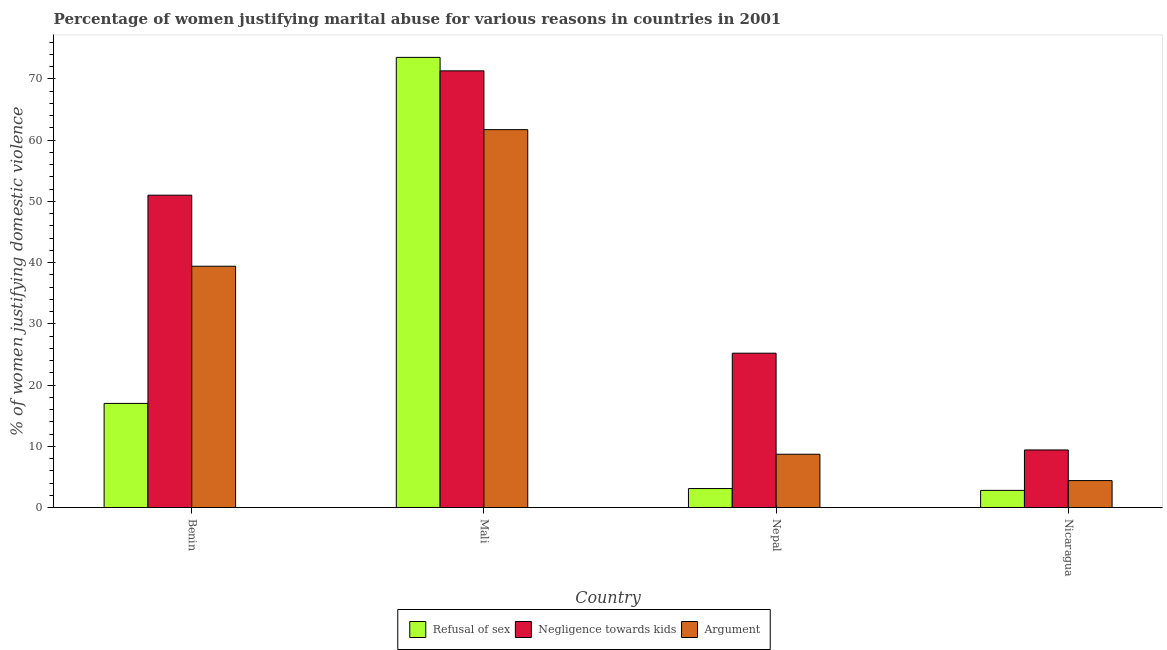Are the number of bars per tick equal to the number of legend labels?
Keep it short and to the point. Yes. What is the label of the 3rd group of bars from the left?
Ensure brevity in your answer.  Nepal. What is the percentage of women justifying domestic violence due to refusal of sex in Benin?
Your answer should be very brief. 17. Across all countries, what is the maximum percentage of women justifying domestic violence due to negligence towards kids?
Ensure brevity in your answer.  71.3. In which country was the percentage of women justifying domestic violence due to refusal of sex maximum?
Offer a terse response. Mali. In which country was the percentage of women justifying domestic violence due to refusal of sex minimum?
Keep it short and to the point. Nicaragua. What is the total percentage of women justifying domestic violence due to arguments in the graph?
Offer a terse response. 114.2. What is the difference between the percentage of women justifying domestic violence due to refusal of sex in Nepal and that in Nicaragua?
Provide a short and direct response. 0.3. What is the difference between the percentage of women justifying domestic violence due to negligence towards kids in Mali and the percentage of women justifying domestic violence due to refusal of sex in Nepal?
Ensure brevity in your answer.  68.2. What is the average percentage of women justifying domestic violence due to arguments per country?
Provide a short and direct response. 28.55. What is the difference between the percentage of women justifying domestic violence due to negligence towards kids and percentage of women justifying domestic violence due to refusal of sex in Mali?
Ensure brevity in your answer.  -2.2. What is the ratio of the percentage of women justifying domestic violence due to refusal of sex in Mali to that in Nicaragua?
Offer a terse response. 26.25. Is the percentage of women justifying domestic violence due to negligence towards kids in Mali less than that in Nepal?
Your answer should be very brief. No. What is the difference between the highest and the second highest percentage of women justifying domestic violence due to negligence towards kids?
Your answer should be compact. 20.3. What is the difference between the highest and the lowest percentage of women justifying domestic violence due to negligence towards kids?
Provide a succinct answer. 61.9. In how many countries, is the percentage of women justifying domestic violence due to refusal of sex greater than the average percentage of women justifying domestic violence due to refusal of sex taken over all countries?
Keep it short and to the point. 1. What does the 2nd bar from the left in Nicaragua represents?
Your answer should be very brief. Negligence towards kids. What does the 1st bar from the right in Mali represents?
Provide a succinct answer. Argument. Are all the bars in the graph horizontal?
Your answer should be very brief. No. How many countries are there in the graph?
Keep it short and to the point. 4. What is the difference between two consecutive major ticks on the Y-axis?
Your response must be concise. 10. Are the values on the major ticks of Y-axis written in scientific E-notation?
Provide a succinct answer. No. Does the graph contain any zero values?
Provide a short and direct response. No. Does the graph contain grids?
Give a very brief answer. No. Where does the legend appear in the graph?
Provide a succinct answer. Bottom center. How many legend labels are there?
Your response must be concise. 3. How are the legend labels stacked?
Provide a succinct answer. Horizontal. What is the title of the graph?
Your response must be concise. Percentage of women justifying marital abuse for various reasons in countries in 2001. What is the label or title of the X-axis?
Offer a very short reply. Country. What is the label or title of the Y-axis?
Provide a short and direct response. % of women justifying domestic violence. What is the % of women justifying domestic violence of Refusal of sex in Benin?
Give a very brief answer. 17. What is the % of women justifying domestic violence of Negligence towards kids in Benin?
Offer a terse response. 51. What is the % of women justifying domestic violence in Argument in Benin?
Make the answer very short. 39.4. What is the % of women justifying domestic violence in Refusal of sex in Mali?
Keep it short and to the point. 73.5. What is the % of women justifying domestic violence of Negligence towards kids in Mali?
Give a very brief answer. 71.3. What is the % of women justifying domestic violence of Argument in Mali?
Provide a succinct answer. 61.7. What is the % of women justifying domestic violence in Refusal of sex in Nepal?
Your answer should be very brief. 3.1. What is the % of women justifying domestic violence in Negligence towards kids in Nepal?
Give a very brief answer. 25.2. What is the % of women justifying domestic violence of Argument in Nepal?
Your response must be concise. 8.7. What is the % of women justifying domestic violence in Refusal of sex in Nicaragua?
Give a very brief answer. 2.8. What is the % of women justifying domestic violence in Argument in Nicaragua?
Give a very brief answer. 4.4. Across all countries, what is the maximum % of women justifying domestic violence of Refusal of sex?
Give a very brief answer. 73.5. Across all countries, what is the maximum % of women justifying domestic violence of Negligence towards kids?
Offer a very short reply. 71.3. Across all countries, what is the maximum % of women justifying domestic violence in Argument?
Provide a short and direct response. 61.7. Across all countries, what is the minimum % of women justifying domestic violence of Refusal of sex?
Give a very brief answer. 2.8. Across all countries, what is the minimum % of women justifying domestic violence of Negligence towards kids?
Give a very brief answer. 9.4. Across all countries, what is the minimum % of women justifying domestic violence of Argument?
Keep it short and to the point. 4.4. What is the total % of women justifying domestic violence of Refusal of sex in the graph?
Provide a succinct answer. 96.4. What is the total % of women justifying domestic violence of Negligence towards kids in the graph?
Ensure brevity in your answer.  156.9. What is the total % of women justifying domestic violence in Argument in the graph?
Provide a short and direct response. 114.2. What is the difference between the % of women justifying domestic violence of Refusal of sex in Benin and that in Mali?
Give a very brief answer. -56.5. What is the difference between the % of women justifying domestic violence of Negligence towards kids in Benin and that in Mali?
Provide a succinct answer. -20.3. What is the difference between the % of women justifying domestic violence in Argument in Benin and that in Mali?
Make the answer very short. -22.3. What is the difference between the % of women justifying domestic violence of Refusal of sex in Benin and that in Nepal?
Your answer should be very brief. 13.9. What is the difference between the % of women justifying domestic violence in Negligence towards kids in Benin and that in Nepal?
Keep it short and to the point. 25.8. What is the difference between the % of women justifying domestic violence in Argument in Benin and that in Nepal?
Ensure brevity in your answer.  30.7. What is the difference between the % of women justifying domestic violence in Negligence towards kids in Benin and that in Nicaragua?
Offer a very short reply. 41.6. What is the difference between the % of women justifying domestic violence in Refusal of sex in Mali and that in Nepal?
Your answer should be very brief. 70.4. What is the difference between the % of women justifying domestic violence in Negligence towards kids in Mali and that in Nepal?
Make the answer very short. 46.1. What is the difference between the % of women justifying domestic violence in Argument in Mali and that in Nepal?
Your response must be concise. 53. What is the difference between the % of women justifying domestic violence in Refusal of sex in Mali and that in Nicaragua?
Your answer should be compact. 70.7. What is the difference between the % of women justifying domestic violence in Negligence towards kids in Mali and that in Nicaragua?
Make the answer very short. 61.9. What is the difference between the % of women justifying domestic violence in Argument in Mali and that in Nicaragua?
Provide a short and direct response. 57.3. What is the difference between the % of women justifying domestic violence of Refusal of sex in Nepal and that in Nicaragua?
Make the answer very short. 0.3. What is the difference between the % of women justifying domestic violence in Refusal of sex in Benin and the % of women justifying domestic violence in Negligence towards kids in Mali?
Provide a short and direct response. -54.3. What is the difference between the % of women justifying domestic violence in Refusal of sex in Benin and the % of women justifying domestic violence in Argument in Mali?
Your response must be concise. -44.7. What is the difference between the % of women justifying domestic violence of Refusal of sex in Benin and the % of women justifying domestic violence of Negligence towards kids in Nepal?
Keep it short and to the point. -8.2. What is the difference between the % of women justifying domestic violence of Negligence towards kids in Benin and the % of women justifying domestic violence of Argument in Nepal?
Your response must be concise. 42.3. What is the difference between the % of women justifying domestic violence of Negligence towards kids in Benin and the % of women justifying domestic violence of Argument in Nicaragua?
Offer a terse response. 46.6. What is the difference between the % of women justifying domestic violence in Refusal of sex in Mali and the % of women justifying domestic violence in Negligence towards kids in Nepal?
Offer a very short reply. 48.3. What is the difference between the % of women justifying domestic violence of Refusal of sex in Mali and the % of women justifying domestic violence of Argument in Nepal?
Make the answer very short. 64.8. What is the difference between the % of women justifying domestic violence in Negligence towards kids in Mali and the % of women justifying domestic violence in Argument in Nepal?
Provide a succinct answer. 62.6. What is the difference between the % of women justifying domestic violence of Refusal of sex in Mali and the % of women justifying domestic violence of Negligence towards kids in Nicaragua?
Offer a very short reply. 64.1. What is the difference between the % of women justifying domestic violence of Refusal of sex in Mali and the % of women justifying domestic violence of Argument in Nicaragua?
Keep it short and to the point. 69.1. What is the difference between the % of women justifying domestic violence of Negligence towards kids in Mali and the % of women justifying domestic violence of Argument in Nicaragua?
Provide a short and direct response. 66.9. What is the difference between the % of women justifying domestic violence of Refusal of sex in Nepal and the % of women justifying domestic violence of Negligence towards kids in Nicaragua?
Offer a very short reply. -6.3. What is the difference between the % of women justifying domestic violence of Refusal of sex in Nepal and the % of women justifying domestic violence of Argument in Nicaragua?
Give a very brief answer. -1.3. What is the difference between the % of women justifying domestic violence in Negligence towards kids in Nepal and the % of women justifying domestic violence in Argument in Nicaragua?
Offer a very short reply. 20.8. What is the average % of women justifying domestic violence in Refusal of sex per country?
Ensure brevity in your answer.  24.1. What is the average % of women justifying domestic violence in Negligence towards kids per country?
Offer a terse response. 39.23. What is the average % of women justifying domestic violence in Argument per country?
Ensure brevity in your answer.  28.55. What is the difference between the % of women justifying domestic violence of Refusal of sex and % of women justifying domestic violence of Negligence towards kids in Benin?
Offer a very short reply. -34. What is the difference between the % of women justifying domestic violence of Refusal of sex and % of women justifying domestic violence of Argument in Benin?
Your answer should be compact. -22.4. What is the difference between the % of women justifying domestic violence of Negligence towards kids and % of women justifying domestic violence of Argument in Benin?
Offer a terse response. 11.6. What is the difference between the % of women justifying domestic violence in Refusal of sex and % of women justifying domestic violence in Negligence towards kids in Mali?
Make the answer very short. 2.2. What is the difference between the % of women justifying domestic violence in Negligence towards kids and % of women justifying domestic violence in Argument in Mali?
Your response must be concise. 9.6. What is the difference between the % of women justifying domestic violence in Refusal of sex and % of women justifying domestic violence in Negligence towards kids in Nepal?
Your answer should be compact. -22.1. What is the difference between the % of women justifying domestic violence of Refusal of sex and % of women justifying domestic violence of Argument in Nepal?
Offer a very short reply. -5.6. What is the difference between the % of women justifying domestic violence of Refusal of sex and % of women justifying domestic violence of Negligence towards kids in Nicaragua?
Your answer should be compact. -6.6. What is the ratio of the % of women justifying domestic violence in Refusal of sex in Benin to that in Mali?
Your answer should be very brief. 0.23. What is the ratio of the % of women justifying domestic violence in Negligence towards kids in Benin to that in Mali?
Offer a terse response. 0.72. What is the ratio of the % of women justifying domestic violence in Argument in Benin to that in Mali?
Your answer should be very brief. 0.64. What is the ratio of the % of women justifying domestic violence in Refusal of sex in Benin to that in Nepal?
Give a very brief answer. 5.48. What is the ratio of the % of women justifying domestic violence of Negligence towards kids in Benin to that in Nepal?
Offer a very short reply. 2.02. What is the ratio of the % of women justifying domestic violence in Argument in Benin to that in Nepal?
Provide a succinct answer. 4.53. What is the ratio of the % of women justifying domestic violence of Refusal of sex in Benin to that in Nicaragua?
Provide a short and direct response. 6.07. What is the ratio of the % of women justifying domestic violence in Negligence towards kids in Benin to that in Nicaragua?
Give a very brief answer. 5.43. What is the ratio of the % of women justifying domestic violence in Argument in Benin to that in Nicaragua?
Your answer should be very brief. 8.95. What is the ratio of the % of women justifying domestic violence of Refusal of sex in Mali to that in Nepal?
Offer a terse response. 23.71. What is the ratio of the % of women justifying domestic violence in Negligence towards kids in Mali to that in Nepal?
Make the answer very short. 2.83. What is the ratio of the % of women justifying domestic violence in Argument in Mali to that in Nepal?
Offer a terse response. 7.09. What is the ratio of the % of women justifying domestic violence in Refusal of sex in Mali to that in Nicaragua?
Give a very brief answer. 26.25. What is the ratio of the % of women justifying domestic violence of Negligence towards kids in Mali to that in Nicaragua?
Give a very brief answer. 7.59. What is the ratio of the % of women justifying domestic violence in Argument in Mali to that in Nicaragua?
Offer a very short reply. 14.02. What is the ratio of the % of women justifying domestic violence of Refusal of sex in Nepal to that in Nicaragua?
Your answer should be very brief. 1.11. What is the ratio of the % of women justifying domestic violence of Negligence towards kids in Nepal to that in Nicaragua?
Your answer should be very brief. 2.68. What is the ratio of the % of women justifying domestic violence in Argument in Nepal to that in Nicaragua?
Provide a short and direct response. 1.98. What is the difference between the highest and the second highest % of women justifying domestic violence of Refusal of sex?
Make the answer very short. 56.5. What is the difference between the highest and the second highest % of women justifying domestic violence of Negligence towards kids?
Provide a short and direct response. 20.3. What is the difference between the highest and the second highest % of women justifying domestic violence in Argument?
Your answer should be very brief. 22.3. What is the difference between the highest and the lowest % of women justifying domestic violence of Refusal of sex?
Ensure brevity in your answer.  70.7. What is the difference between the highest and the lowest % of women justifying domestic violence in Negligence towards kids?
Provide a succinct answer. 61.9. What is the difference between the highest and the lowest % of women justifying domestic violence of Argument?
Your answer should be compact. 57.3. 